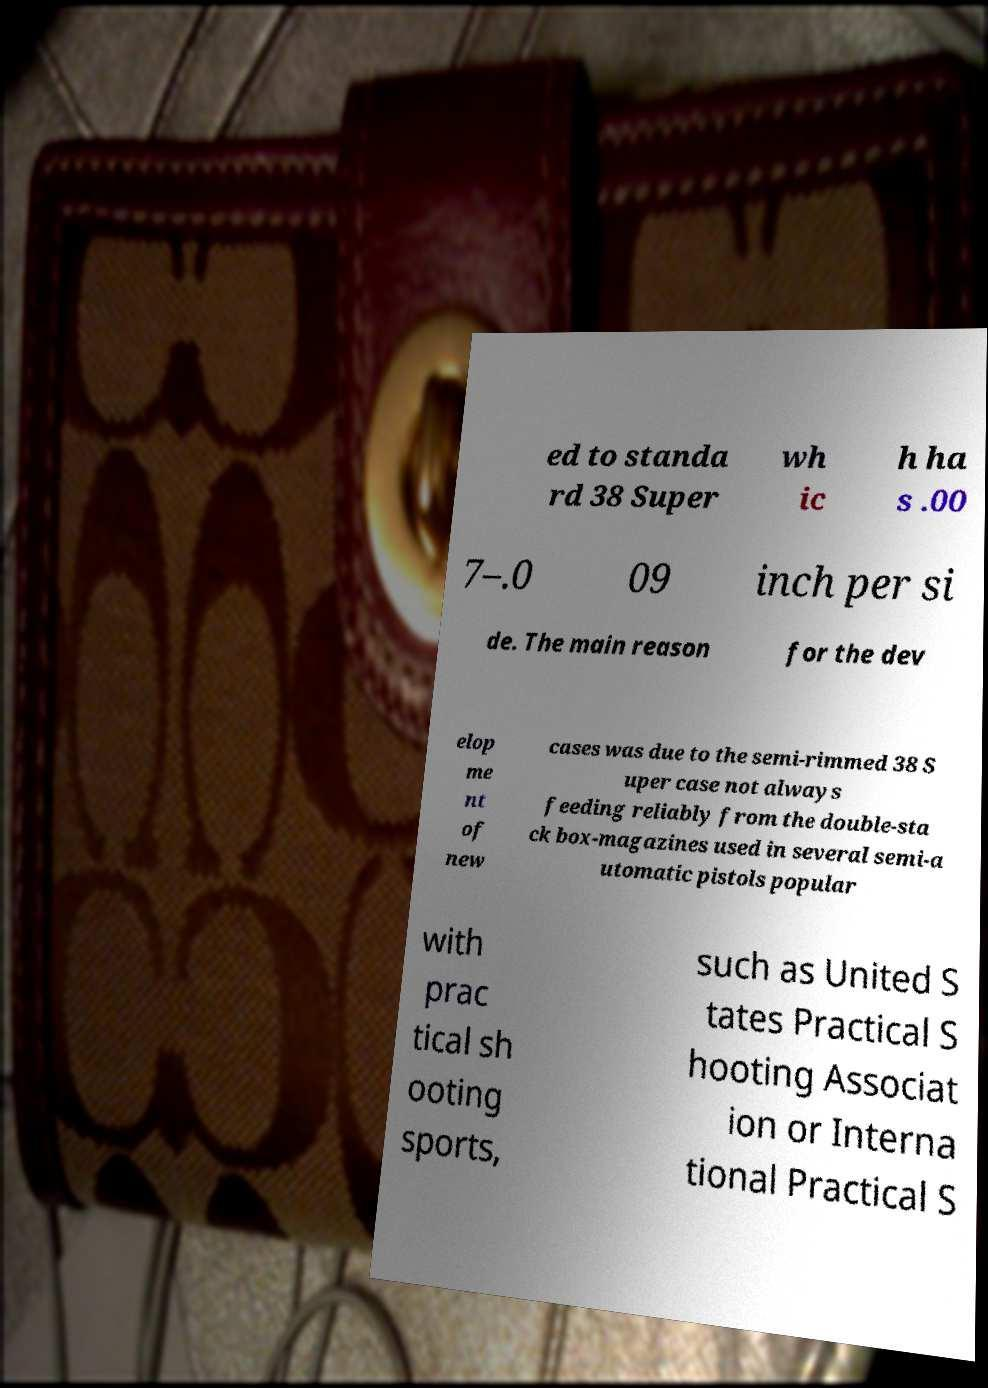Can you accurately transcribe the text from the provided image for me? ed to standa rd 38 Super wh ic h ha s .00 7–.0 09 inch per si de. The main reason for the dev elop me nt of new cases was due to the semi-rimmed 38 S uper case not always feeding reliably from the double-sta ck box-magazines used in several semi-a utomatic pistols popular with prac tical sh ooting sports, such as United S tates Practical S hooting Associat ion or Interna tional Practical S 